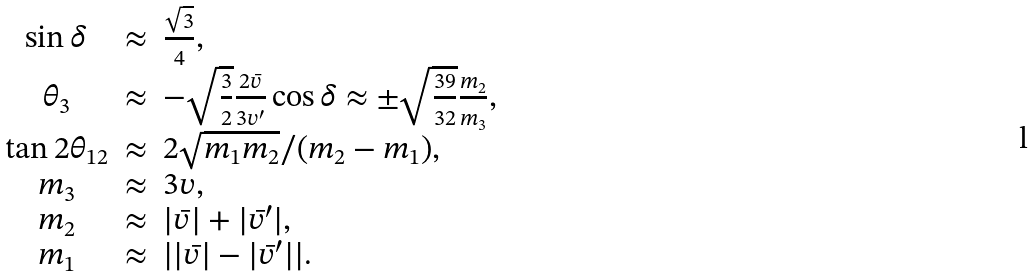Convert formula to latex. <formula><loc_0><loc_0><loc_500><loc_500>\begin{array} { c c l } \sin \delta & \approx & \frac { \sqrt { 3 } } { 4 } , \\ \theta _ { 3 } & \approx & - \sqrt { \frac { 3 } { 2 } } \frac { 2 \bar { v } } { 3 v ^ { \prime } } \cos \delta \approx \pm \sqrt { \frac { 3 9 } { 3 2 } } \frac { m _ { 2 } } { m _ { 3 } } , \\ \tan 2 \theta _ { 1 2 } & \approx & 2 { \sqrt { m _ { 1 } m _ { 2 } } } / { ( m _ { 2 } - m _ { 1 } ) } , \\ m _ { 3 } & \approx & 3 v , \\ m _ { 2 } & \approx & | \bar { v } | + | \bar { v } ^ { \prime } | , \\ m _ { 1 } & \approx & | | \bar { v } | - | \bar { v } ^ { \prime } | | . \end{array}</formula> 